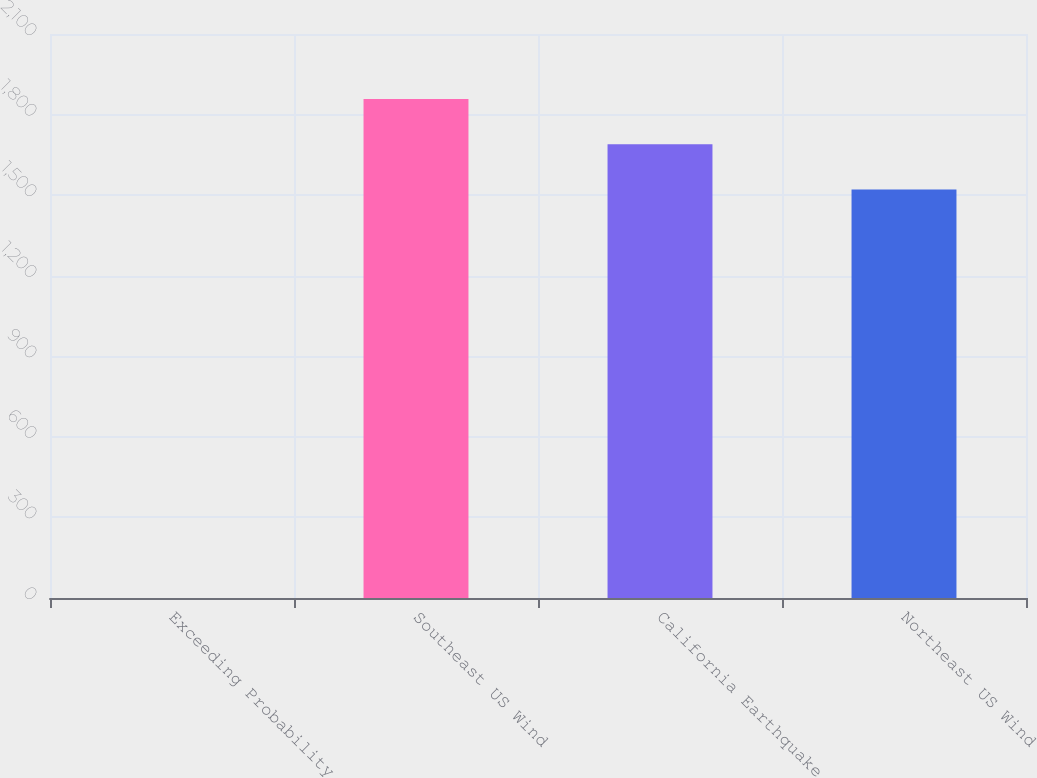<chart> <loc_0><loc_0><loc_500><loc_500><bar_chart><fcel>Exceeding Probability<fcel>Southeast US Wind<fcel>California Earthquake<fcel>Northeast US Wind<nl><fcel>0.1<fcel>1857.98<fcel>1689.49<fcel>1521<nl></chart> 